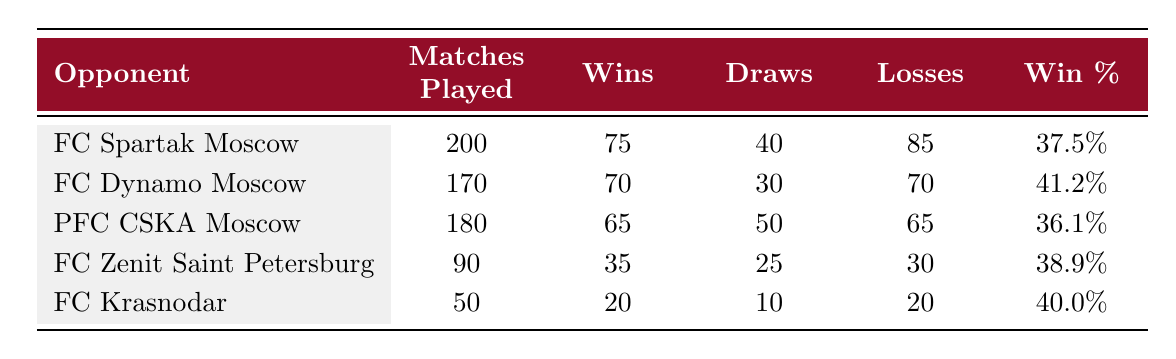What is FC Lokomotiv Moscow's win percentage against FC Spartak Moscow? To find the win percentage against FC Spartak Moscow, we look at the Wins and Matches Played columns for this opponent. The win percentage is calculated as (Wins / Matches Played) * 100. Here, it is (75 / 200) * 100 = 37.5%.
Answer: 37.5% Which team has the lowest number of wins against FC Lokomotiv Moscow? By examining the Wins column, we see that FC Krasnodar has the lowest number of wins with 20.
Answer: FC Krasnodar How many total matches has FC Lokomotiv Moscow played against all listed rivals? To find the total matches played, we sum the Matches Played column: 200 + 170 + 180 + 90 + 50 = 690.
Answer: 690 What is the difference in number of wins between FC Dynamo Moscow and PFC CSKA Moscow? From the table, FC Dynamo Moscow has 70 wins and PFC CSKA Moscow has 65 wins. The difference is 70 - 65 = 5.
Answer: 5 Is it true that FC Lokomotiv Moscow has more wins than losses against FC Zenit Saint Petersburg? FC Lokomotiv Moscow has 35 wins and 30 losses against FC Zenit Saint Petersburg. Since 35 > 30, the statement is true.
Answer: Yes What is the average number of draws against all opponents listed? To find the average draws, we sum the Draws column (40 + 30 + 50 + 25 + 10 = 155) and divide by the number of rivals (5). So, 155 / 5 = 31.
Answer: 31 Which opponent has the highest loss count against FC Lokomotiv Moscow? By reviewing the Losses column, FC Spartak Moscow has the highest loss count with 85 losses.
Answer: FC Spartak Moscow How many matches did FC Lokomotiv Moscow draw against PFC CSKA Moscow and FC Zenit Saint Petersburg combined? Adding the draws for these two teams gives: 50 (CSKA) + 25 (Zenit) = 75.
Answer: 75 What percentage of matches against FC Krasnodar resulted in draws? The percentage of draws is calculated as (Draws / Matches Played) * 100. For FC Krasnodar, it is (10 / 50) * 100 = 20%.
Answer: 20% 